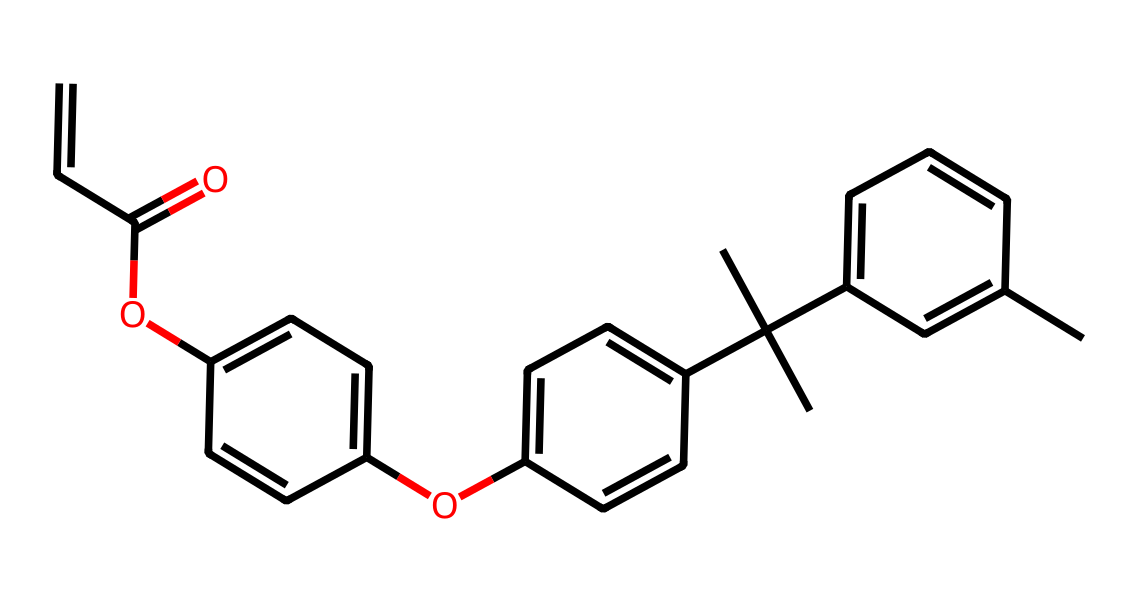What is the total number of carbon atoms in this compound? By examining the SMILES representation, we count the carbon atoms denoted by "C." There are 20 carbon atoms in the structure.
Answer: 20 How many aromatic rings are present in this molecule? Analyzing the structure, we identify three distinct aromatic rings due to the alternating double bonds (which can be indicated by "C=C" in the SMILES).
Answer: 3 What functional groups are indicated in this chemical structure? We can identify two ether groups (due to "OC") and one ester group (indicated by "C(=O)"). These groups classify the molecule's functional characteristics.
Answer: ether and ester Which part of the molecule contributes to its heat resistance? The multiple aromatic rings present in the compound provide thermal stability, as they can effectively dissipate heat.
Answer: aromatic rings What is the degree of unsaturation in this molecule? The degree of unsaturation can be calculated by counting the number of rings and double bonds in the structure. Given the number of rings and double bonds, the degree of unsaturation is determined to be 10.
Answer: 10 